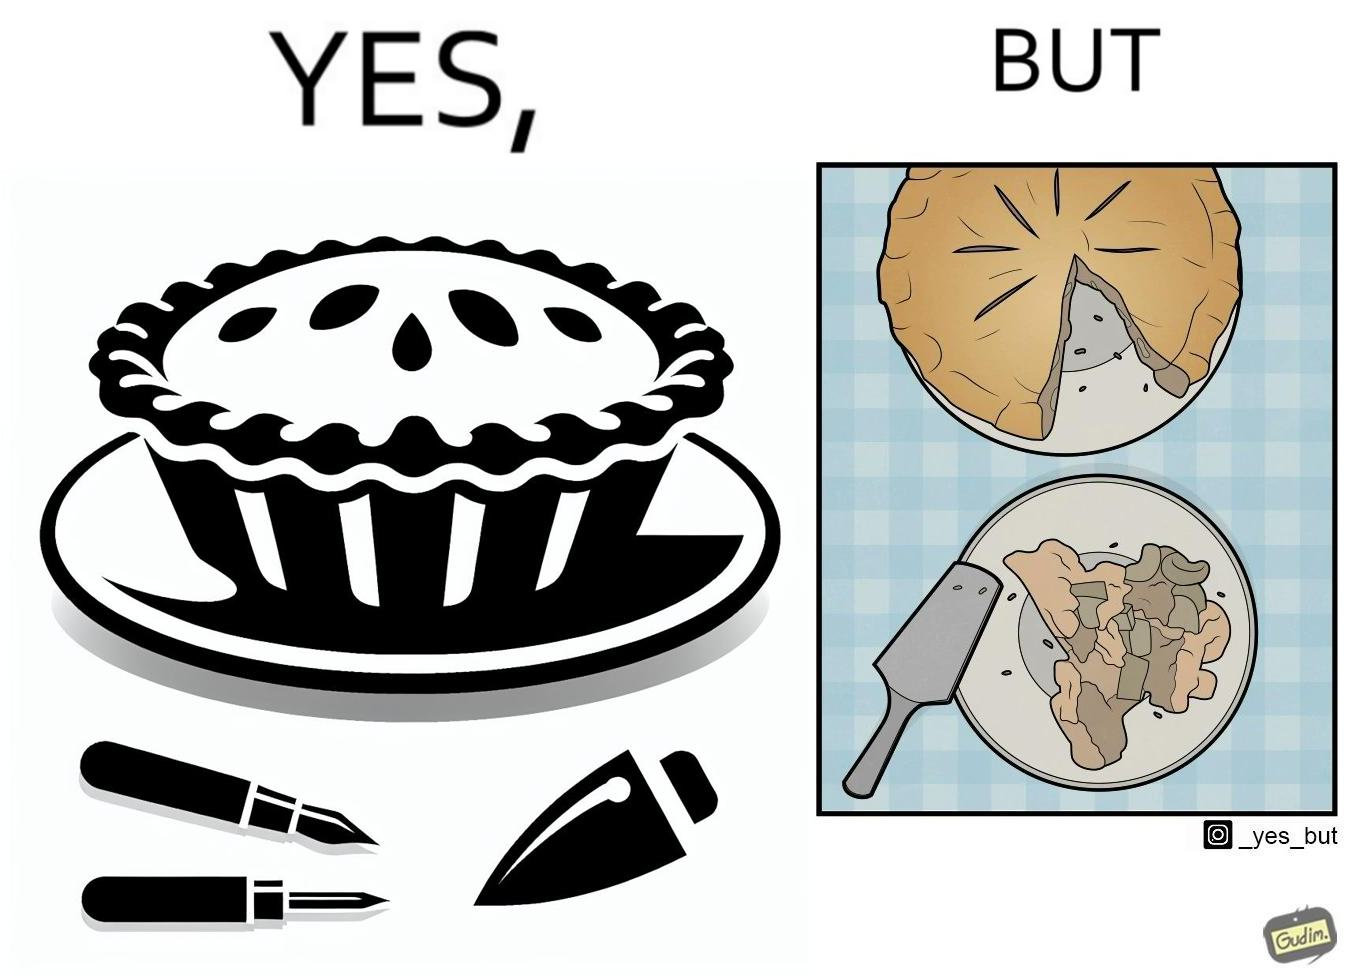What is shown in this image? The image is funny because why people like to get whole pies, they only end up eating a small portion of it wasting the rest of the pie. 